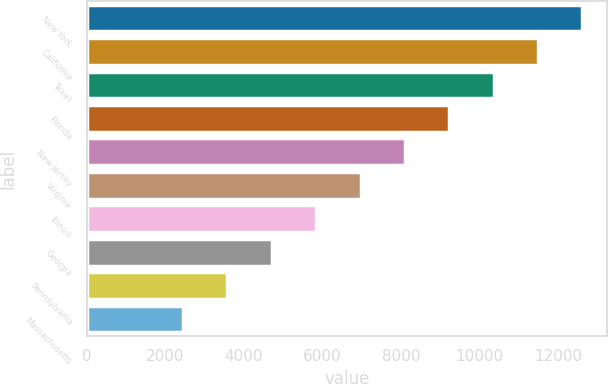<chart> <loc_0><loc_0><loc_500><loc_500><bar_chart><fcel>New York<fcel>California<fcel>Texas<fcel>Florida<fcel>New Jersey<fcel>Virginia<fcel>Illinois<fcel>Georgia<fcel>Pennsylvania<fcel>Massachusetts<nl><fcel>12610.3<fcel>11482<fcel>10353.7<fcel>9225.4<fcel>8097.1<fcel>6968.8<fcel>5840.5<fcel>4712.2<fcel>3583.9<fcel>2455.6<nl></chart> 